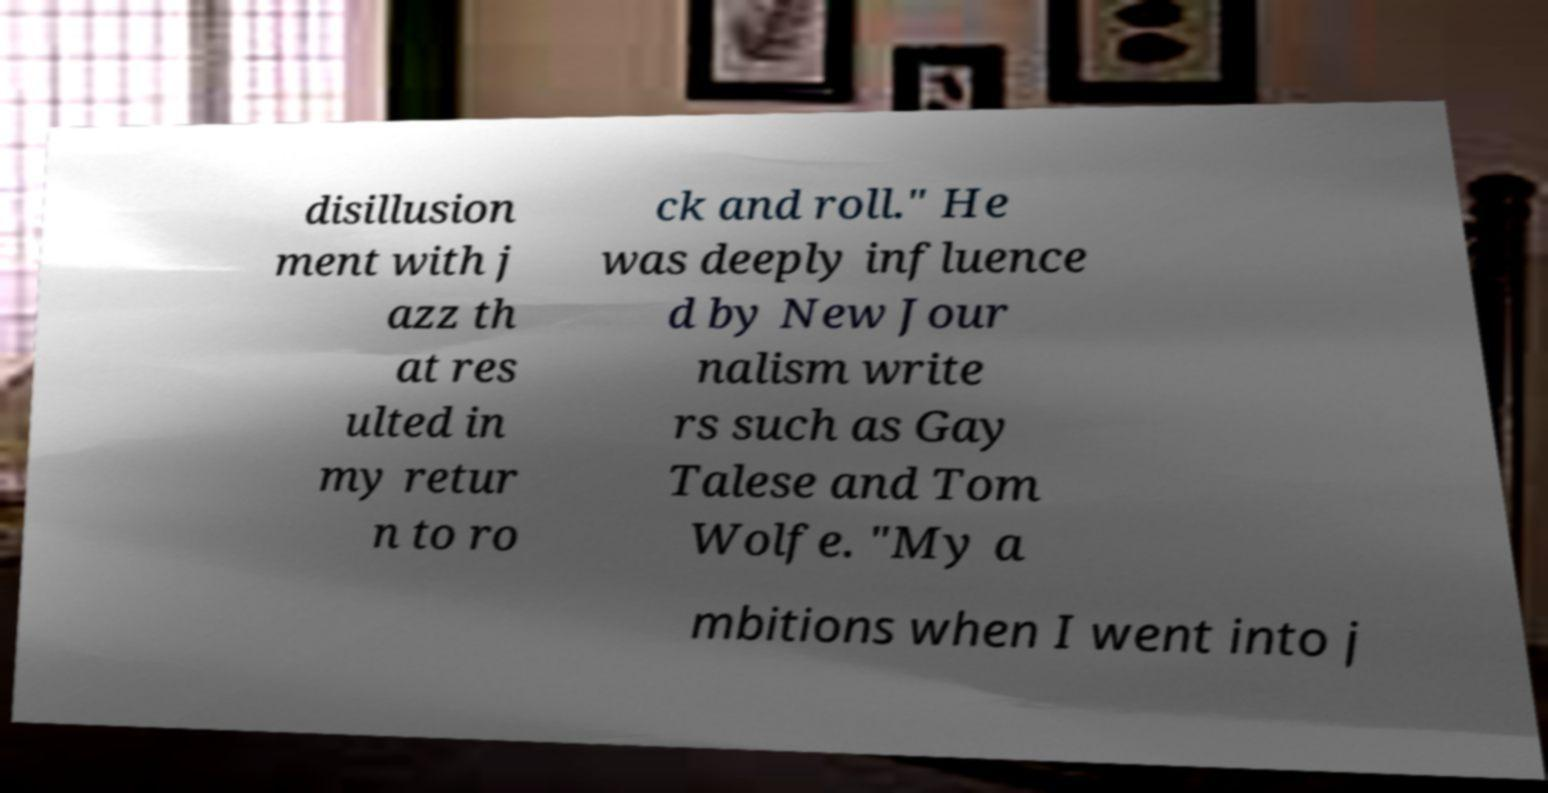For documentation purposes, I need the text within this image transcribed. Could you provide that? disillusion ment with j azz th at res ulted in my retur n to ro ck and roll." He was deeply influence d by New Jour nalism write rs such as Gay Talese and Tom Wolfe. "My a mbitions when I went into j 